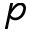Convert formula to latex. <formula><loc_0><loc_0><loc_500><loc_500>p</formula> 